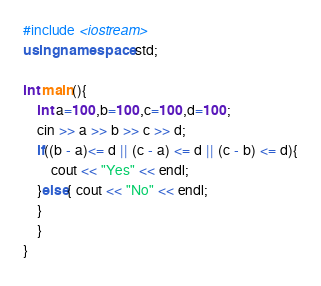<code> <loc_0><loc_0><loc_500><loc_500><_C++_>#include <iostream>
using namespace std;

int main(){
    int a=100,b=100,c=100,d=100;
    cin >> a >> b >> c >> d;
    if((b - a)<= d || (c - a) <= d || (c - b) <= d){
        cout << "Yes" << endl;
    }else{ cout << "No" << endl;
    }
    }
}</code> 